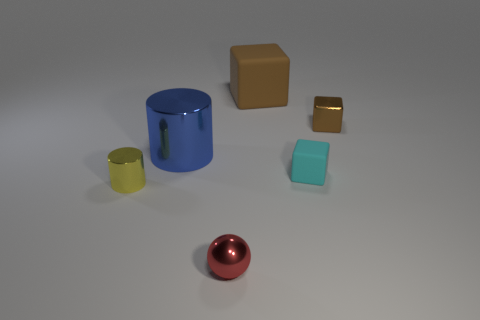There is a shiny cylinder right of the yellow object; is it the same size as the tiny yellow metal thing? No, the shiny cylinder to the right of the yellow object is larger in size compared to the tiny yellow metal thing. The cylinder has a greater height and diameter. 